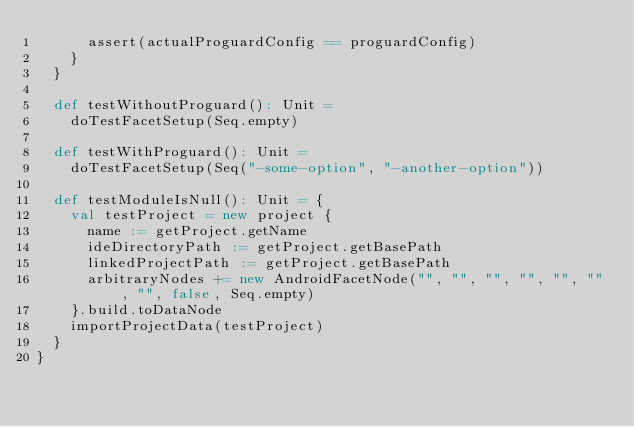<code> <loc_0><loc_0><loc_500><loc_500><_Scala_>      assert(actualProguardConfig == proguardConfig)
    }
  }

  def testWithoutProguard(): Unit =
    doTestFacetSetup(Seq.empty)

  def testWithProguard(): Unit =
    doTestFacetSetup(Seq("-some-option", "-another-option"))

  def testModuleIsNull(): Unit = {
    val testProject = new project {
      name := getProject.getName
      ideDirectoryPath := getProject.getBasePath
      linkedProjectPath := getProject.getBasePath
      arbitraryNodes += new AndroidFacetNode("", "", "", "", "", "", "", false, Seq.empty)
    }.build.toDataNode
    importProjectData(testProject)
  }
}
</code> 